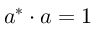<formula> <loc_0><loc_0><loc_500><loc_500>a ^ { * } \cdot a = 1</formula> 